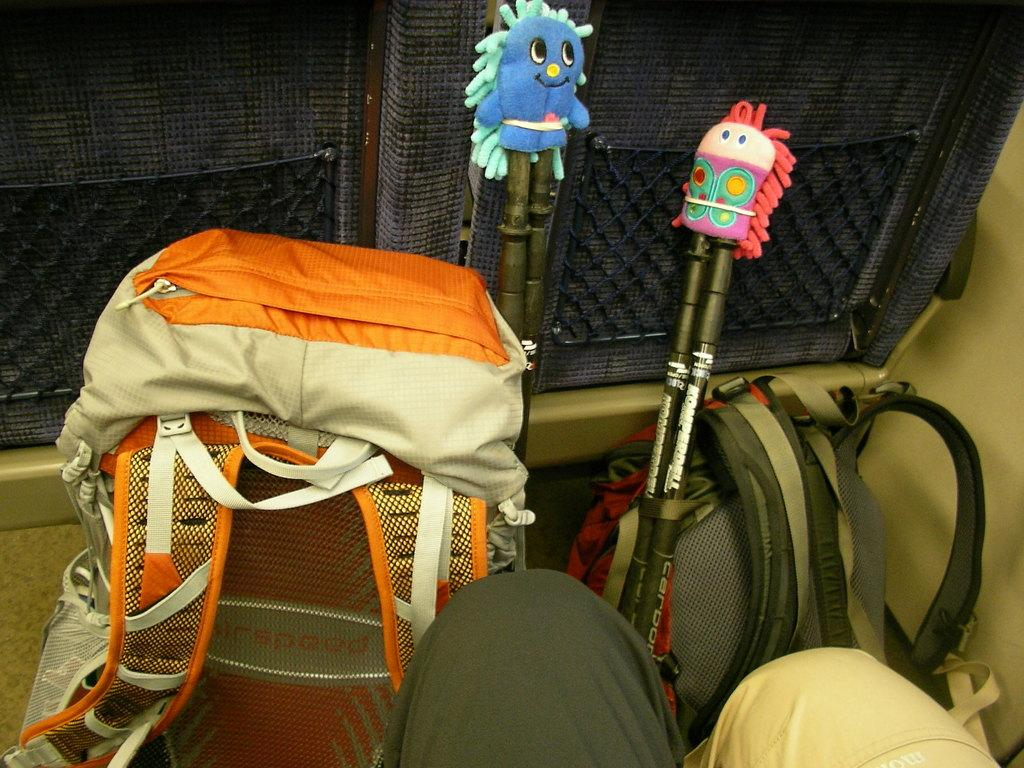How many bags are visible in the image? There are two bags in the image. What else can be seen in the image besides the bags? There are two pairs of sticks in the image. What arithmetic problem is being solved by the daughter in the image? There is no daughter present in the image, and no arithmetic problem is being solved. 